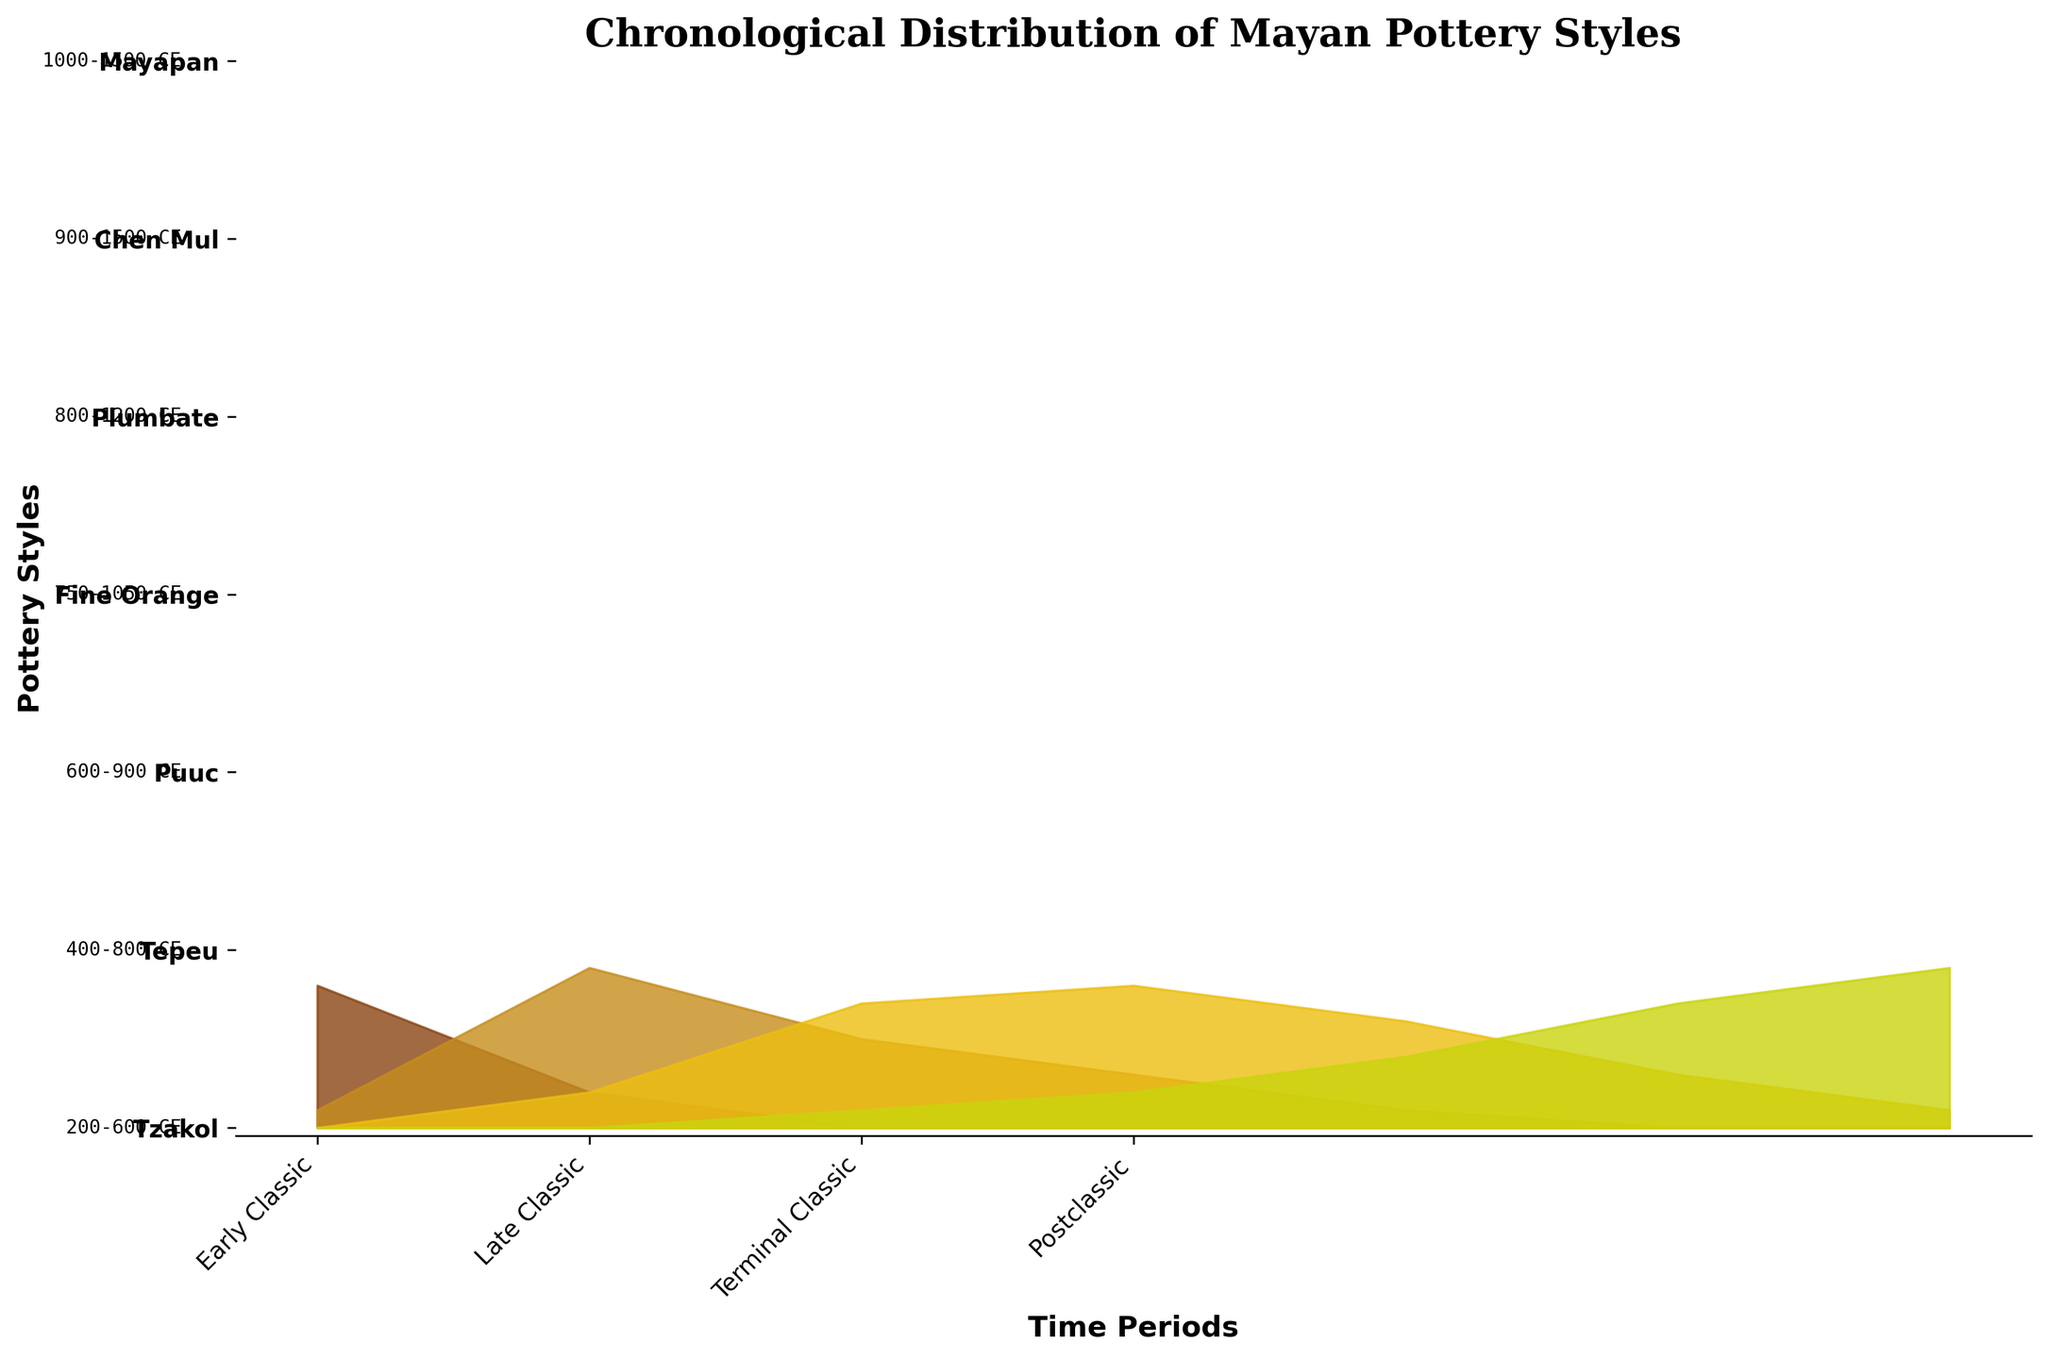What is the title of the figure? The title is usually located at the top of the figure and can be read directly.
Answer: Chronological Distribution of Mayan Pottery Styles What is the time period associated with the Tzakol style? The period is denoted alongside each pottery style on the left side of the figure. For the Tzakol style, the period is given as 200-600 CE.
Answer: 200-600 CE Which pottery style has the highest presence in the Postclassic period? By observing the height of the ridgelines, the Mayapan style has the highest fill in the Postclassic period indicating its dominance.
Answer: Mayapan Between the Late Classic and Terminal Classic periods, which style shows an increase in presence? Comparing their relative heights between the periods, the Puuc and Fine Orange styles show an increase from Late Classic to Terminal Classic.
Answer: Puuc, Fine Orange What is the visual difference observed in the representation of the Early Classic and Terminal Classic periods for the Tzakol style? The Tzakol style has a significant presence in the Early Classic (represented by a high fill), while it has no presence in the Terminal Classic (represented by zero fill).
Answer: Tzakol present in Early Classic, absent in Terminal Classic Which style spans all the way from the Late Classic to the Postclassic period? The Chen Mul and Mayapan styles span multiple periods, but only Chen Mul spans from Late Classic to the Postclassic period.
Answer: Chen Mul How does the representation of Plumbate style change from Terminal Classic to Postclassic? The Plumbate style shows a moderate presence in the Terminal Classic and slightly less in the Postclassic period as signified by the decreasing height in the ridgelines.
Answer: Decreases from Terminal Classic to Postclassic Identify the styles that show any presence in both the Postclassic and Terminal Classic periods. The ridgelines for Fine Orange and Plumbate display some height in both the Terminal Classic and Postclassic periods.
Answer: Fine Orange, Plumbate Which pottery style has no presence in the Early Classic period but shows significant presence in the Postclassic period? Observing the ridgeline for Mayapan, it starts in the Postclassic period and has no presence in the Early Classic period.
Answer: Mayapan Compare the presence of the Puuc style in the Terminal Classic and Postclassic periods. The Puuc style has a higher representation in the Terminal Classic (tall ridgeline) than in the Postclassic (short ridgeline).
Answer: Higher in Terminal Classic 